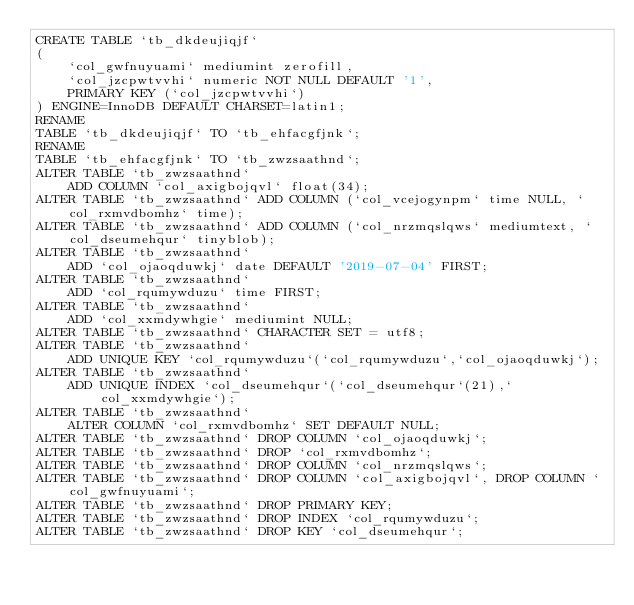Convert code to text. <code><loc_0><loc_0><loc_500><loc_500><_SQL_>CREATE TABLE `tb_dkdeujiqjf`
(
    `col_gwfnuyuami` mediumint zerofill,
    `col_jzcpwtvvhi` numeric NOT NULL DEFAULT '1',
    PRIMARY KEY (`col_jzcpwtvvhi`)
) ENGINE=InnoDB DEFAULT CHARSET=latin1;
RENAME
TABLE `tb_dkdeujiqjf` TO `tb_ehfacgfjnk`;
RENAME
TABLE `tb_ehfacgfjnk` TO `tb_zwzsaathnd`;
ALTER TABLE `tb_zwzsaathnd`
    ADD COLUMN `col_axigbojqvl` float(34);
ALTER TABLE `tb_zwzsaathnd` ADD COLUMN (`col_vcejogynpm` time NULL, `col_rxmvdbomhz` time);
ALTER TABLE `tb_zwzsaathnd` ADD COLUMN (`col_nrzmqslqws` mediumtext, `col_dseumehqur` tinyblob);
ALTER TABLE `tb_zwzsaathnd`
    ADD `col_ojaoqduwkj` date DEFAULT '2019-07-04' FIRST;
ALTER TABLE `tb_zwzsaathnd`
    ADD `col_rqumywduzu` time FIRST;
ALTER TABLE `tb_zwzsaathnd`
    ADD `col_xxmdywhgie` mediumint NULL;
ALTER TABLE `tb_zwzsaathnd` CHARACTER SET = utf8;
ALTER TABLE `tb_zwzsaathnd`
    ADD UNIQUE KEY `col_rqumywduzu`(`col_rqumywduzu`,`col_ojaoqduwkj`);
ALTER TABLE `tb_zwzsaathnd`
    ADD UNIQUE INDEX `col_dseumehqur`(`col_dseumehqur`(21),`col_xxmdywhgie`);
ALTER TABLE `tb_zwzsaathnd`
    ALTER COLUMN `col_rxmvdbomhz` SET DEFAULT NULL;
ALTER TABLE `tb_zwzsaathnd` DROP COLUMN `col_ojaoqduwkj`;
ALTER TABLE `tb_zwzsaathnd` DROP `col_rxmvdbomhz`;
ALTER TABLE `tb_zwzsaathnd` DROP COLUMN `col_nrzmqslqws`;
ALTER TABLE `tb_zwzsaathnd` DROP COLUMN `col_axigbojqvl`, DROP COLUMN `col_gwfnuyuami`;
ALTER TABLE `tb_zwzsaathnd` DROP PRIMARY KEY;
ALTER TABLE `tb_zwzsaathnd` DROP INDEX `col_rqumywduzu`;
ALTER TABLE `tb_zwzsaathnd` DROP KEY `col_dseumehqur`;
</code> 